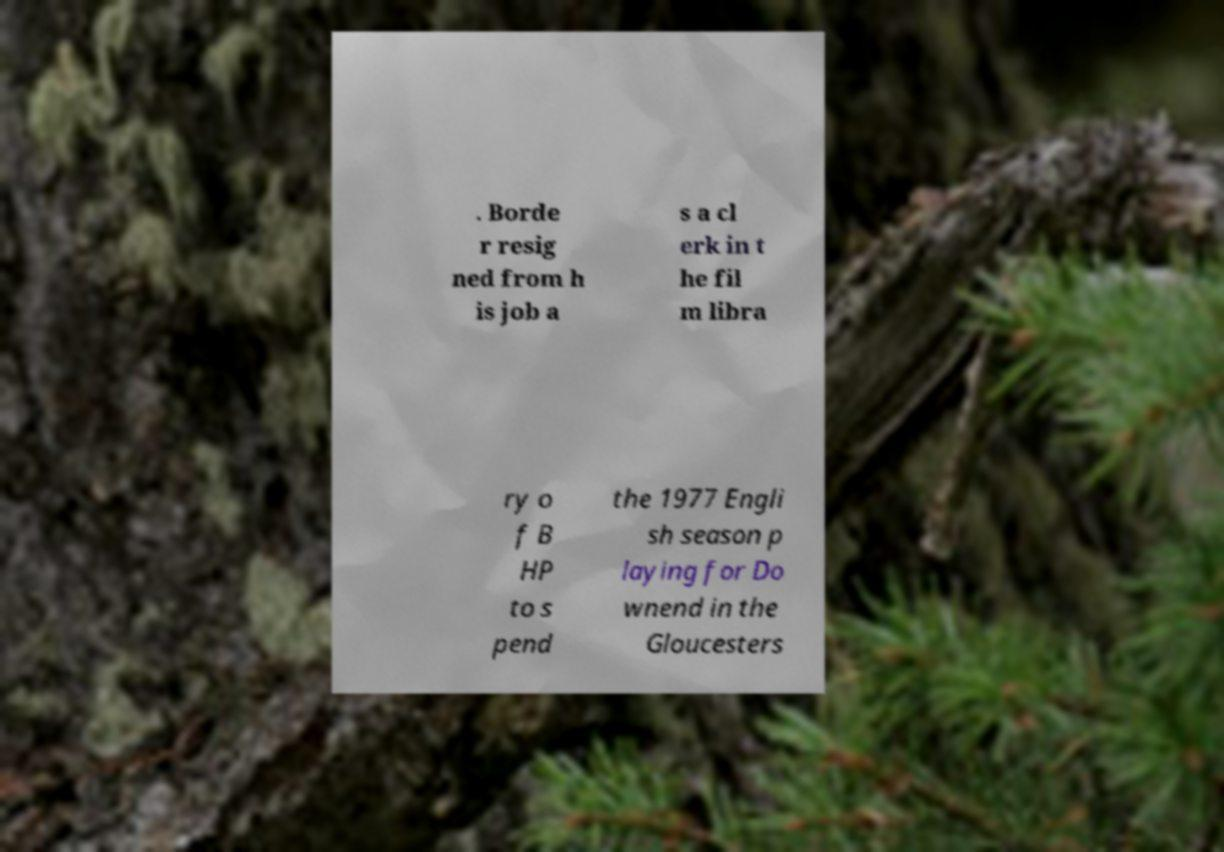Could you assist in decoding the text presented in this image and type it out clearly? . Borde r resig ned from h is job a s a cl erk in t he fil m libra ry o f B HP to s pend the 1977 Engli sh season p laying for Do wnend in the Gloucesters 